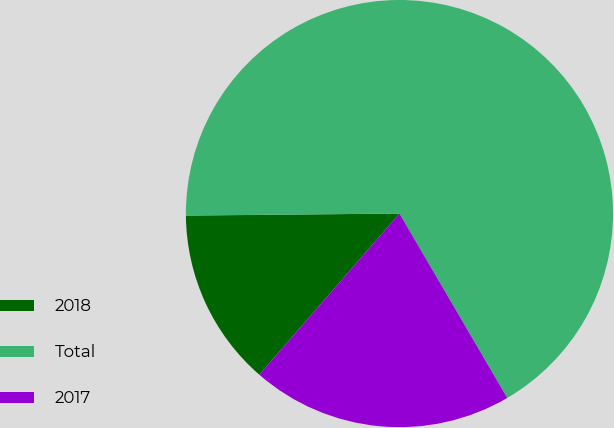Convert chart. <chart><loc_0><loc_0><loc_500><loc_500><pie_chart><fcel>2018<fcel>Total<fcel>2017<nl><fcel>13.46%<fcel>66.73%<fcel>19.81%<nl></chart> 